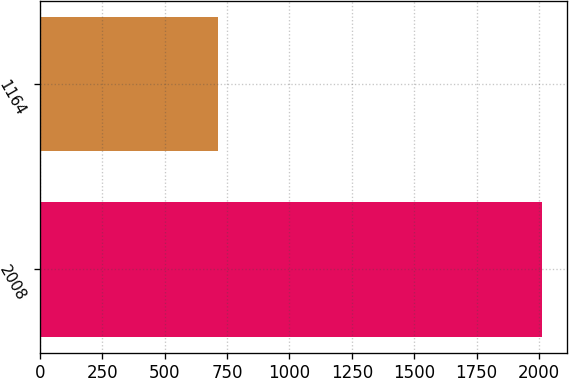Convert chart to OTSL. <chart><loc_0><loc_0><loc_500><loc_500><bar_chart><fcel>2008<fcel>1164<nl><fcel>2010<fcel>715<nl></chart> 